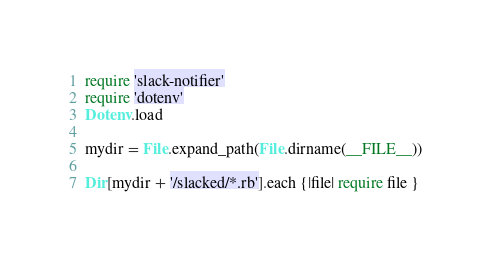<code> <loc_0><loc_0><loc_500><loc_500><_Ruby_>require 'slack-notifier'
require 'dotenv'
Dotenv.load

mydir = File.expand_path(File.dirname(__FILE__))

Dir[mydir + '/slacked/*.rb'].each {|file| require file }
</code> 